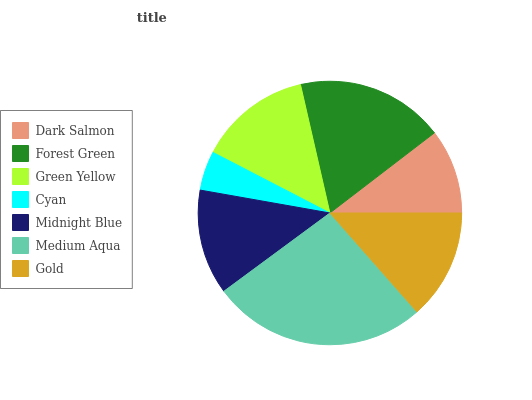Is Cyan the minimum?
Answer yes or no. Yes. Is Medium Aqua the maximum?
Answer yes or no. Yes. Is Forest Green the minimum?
Answer yes or no. No. Is Forest Green the maximum?
Answer yes or no. No. Is Forest Green greater than Dark Salmon?
Answer yes or no. Yes. Is Dark Salmon less than Forest Green?
Answer yes or no. Yes. Is Dark Salmon greater than Forest Green?
Answer yes or no. No. Is Forest Green less than Dark Salmon?
Answer yes or no. No. Is Gold the high median?
Answer yes or no. Yes. Is Gold the low median?
Answer yes or no. Yes. Is Medium Aqua the high median?
Answer yes or no. No. Is Cyan the low median?
Answer yes or no. No. 